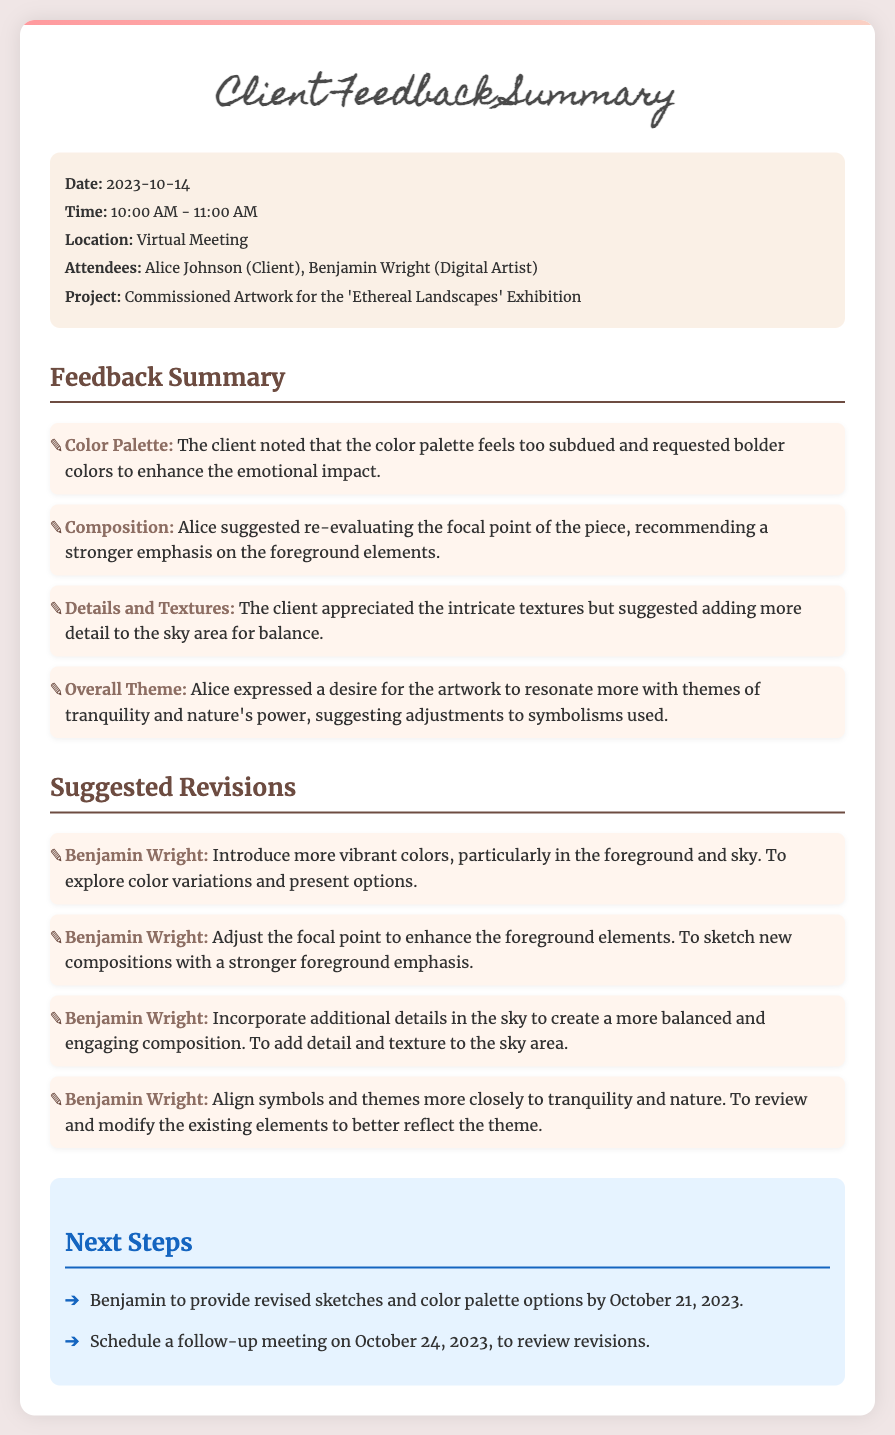What date was the feedback meeting held? The document specifies the meeting date as October 14, 2023.
Answer: October 14, 2023 Who attended the meeting as the client? The attendees of the meeting included Alice Johnson as the client.
Answer: Alice Johnson What was the main project discussed in the meeting? The main project discussed was the commissioned artwork for the 'Ethereal Landscapes' Exhibition.
Answer: Ethereal Landscapes What specific aspect of the artwork did the client want to be adjusted for more emotional impact? The client requested bolder colors to enhance the emotional impact of the artwork.
Answer: Bolder colors How many revisions are suggested for the artwork? The document lists four suggested revisions for the artwork.
Answer: Four What is one of the next steps mentioned in the document? One of the next steps is for Benjamin to provide revised sketches and color palette options.
Answer: Provide revised sketches and color palette options What theme should the artwork resonate more with according to the client? The client expressed a desire for the artwork to resonate more with themes of tranquility and nature's power.
Answer: Tranquility and nature's power When is the follow-up meeting scheduled? The follow-up meeting is scheduled for October 24, 2023.
Answer: October 24, 2023 